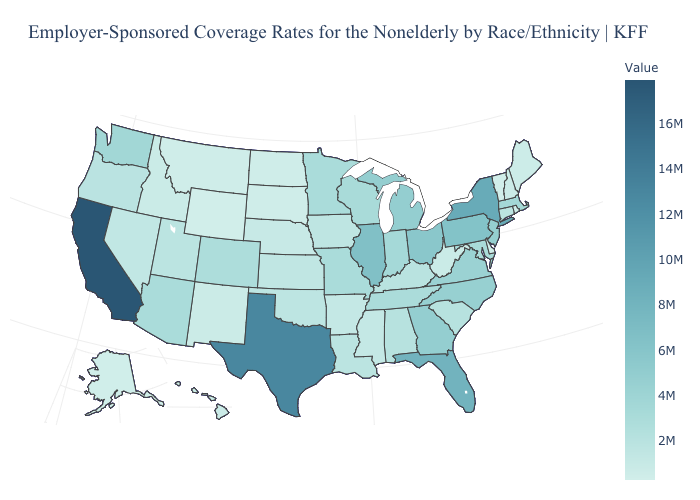Which states have the lowest value in the USA?
Be succinct. Vermont. Does North Carolina have the highest value in the USA?
Keep it brief. No. Does California have the highest value in the USA?
Keep it brief. Yes. Does California have the highest value in the West?
Be succinct. Yes. 